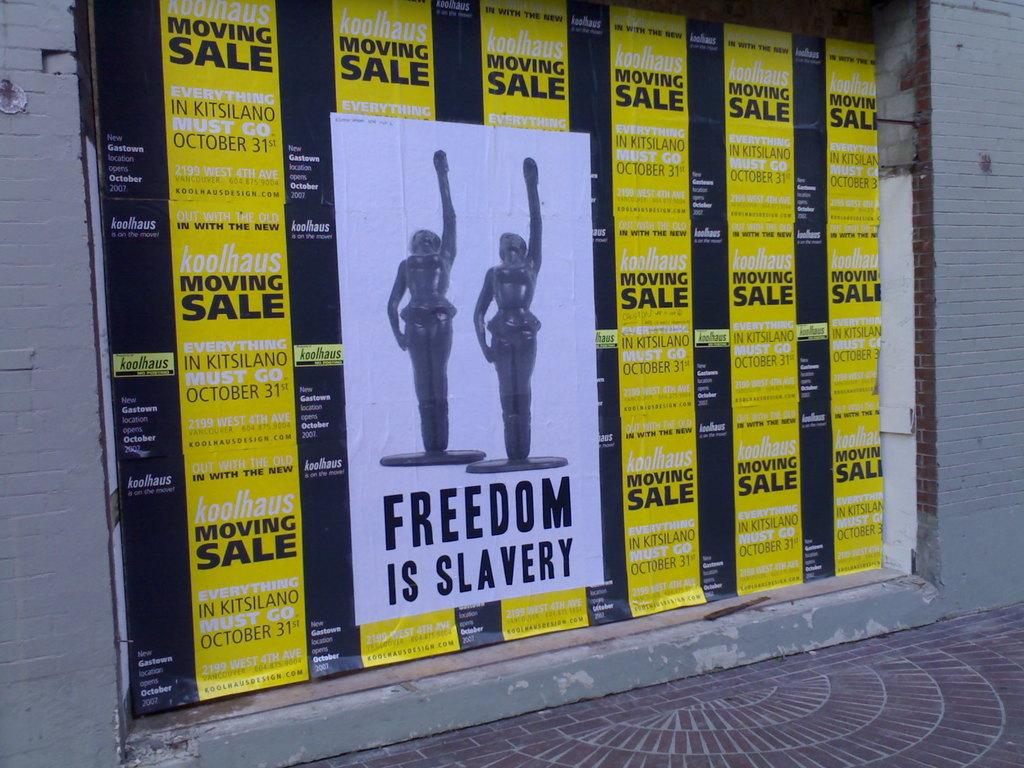Provide a one-sentence caption for the provided image. Moving sale advertisements are the background of a Freedom is Slavery poster. 